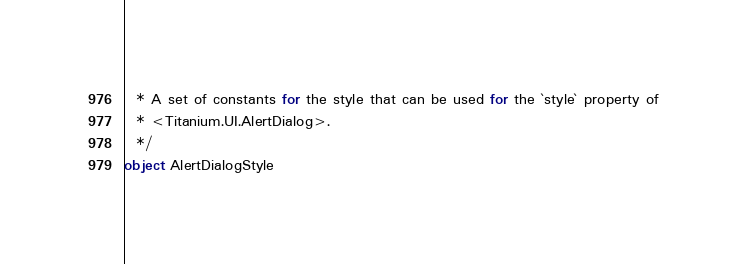<code> <loc_0><loc_0><loc_500><loc_500><_Scala_>  * A set of constants for the style that can be used for the `style` property of
  * <Titanium.UI.AlertDialog>.
  */
object AlertDialogStyle
</code> 